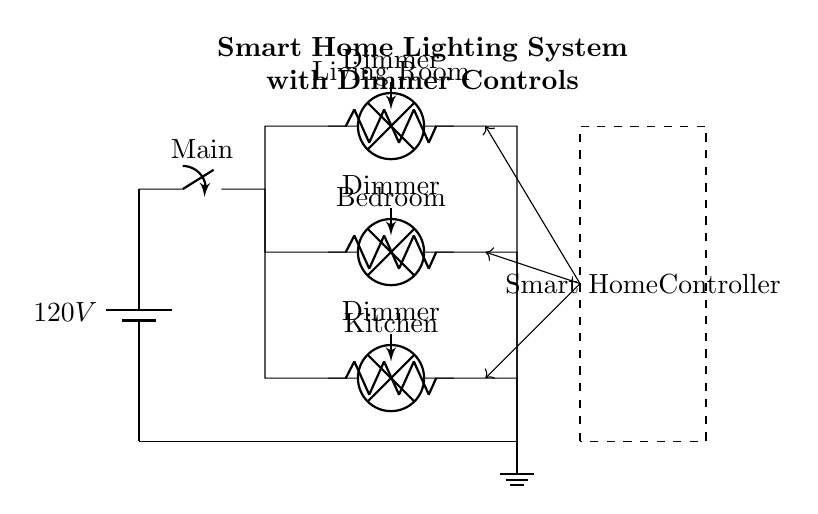What is the main voltage of the circuit? The main voltage is 120V, as indicated by the battery symbol in the diagram.
Answer: 120V What components are connected in parallel? The circuit shows three lamps (Living Room, Bedroom, Kitchen) connected in parallel, as they share the same two potentials without being connected in series.
Answer: Three lamps How many dimmer controls are present? There are three dimmer controls, each associated with one lamp and positioned in parallel connection with the lamps.
Answer: Three dimmer controls What is the function of the smart home controller? The smart home controller allows for remote operation, indicated by the dashed rectangle around it, and it sends signals to modify the state of each lamp independently.
Answer: Remote operation If the Living Room lamp has a resistance of 60 ohms, what is the total current supplied in the parallel circuit if they all operate together? First, we recognize that in a parallel circuit, the total current is the sum of the currents through each branch. However, without the resistance value for the other two lamps, we can’t calculate total current. Still, the individual current can be found using the formula I = V/R. Assuming equal resistance, the total would exist as I total = I Living Room + I Bedroom + I Kitchen. This requires additional values for accurate computation.
Answer: Indeterminate without specific resistances 